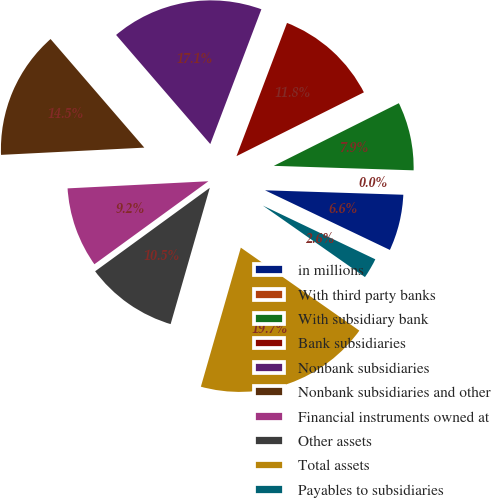Convert chart to OTSL. <chart><loc_0><loc_0><loc_500><loc_500><pie_chart><fcel>in millions<fcel>With third party banks<fcel>With subsidiary bank<fcel>Bank subsidiaries<fcel>Nonbank subsidiaries<fcel>Nonbank subsidiaries and other<fcel>Financial instruments owned at<fcel>Other assets<fcel>Total assets<fcel>Payables to subsidiaries<nl><fcel>6.58%<fcel>0.0%<fcel>7.9%<fcel>11.84%<fcel>17.1%<fcel>14.47%<fcel>9.21%<fcel>10.53%<fcel>19.73%<fcel>2.63%<nl></chart> 